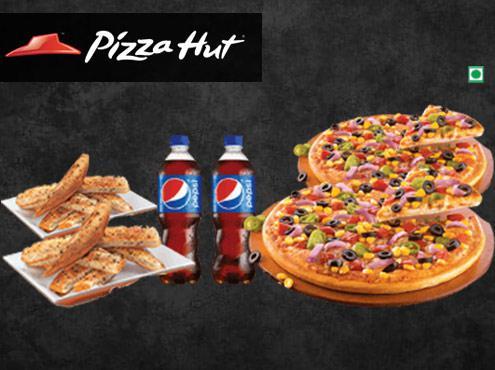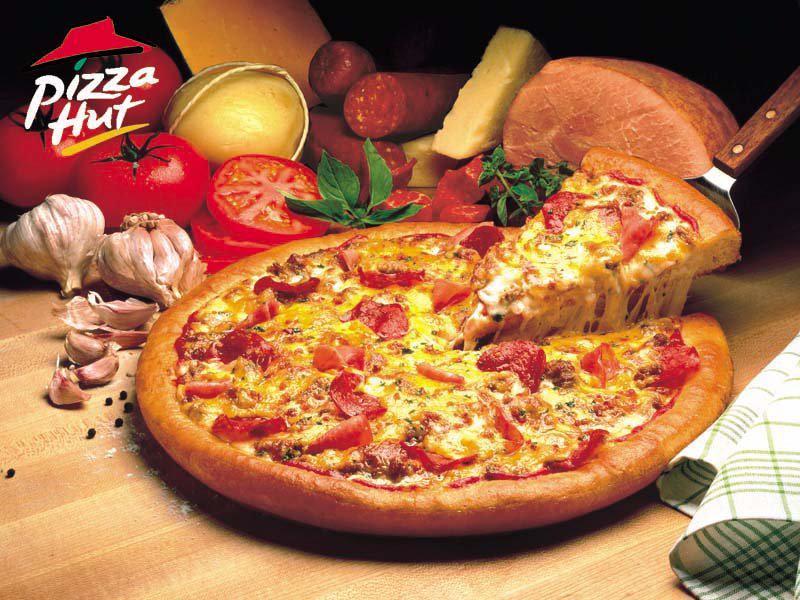The first image is the image on the left, the second image is the image on the right. Examine the images to the left and right. Is the description "There are two bottles of soda pictured." accurate? Answer yes or no. Yes. The first image is the image on the left, the second image is the image on the right. For the images shown, is this caption "A single bottle of soda sits near pizza in the image on the right." true? Answer yes or no. No. 